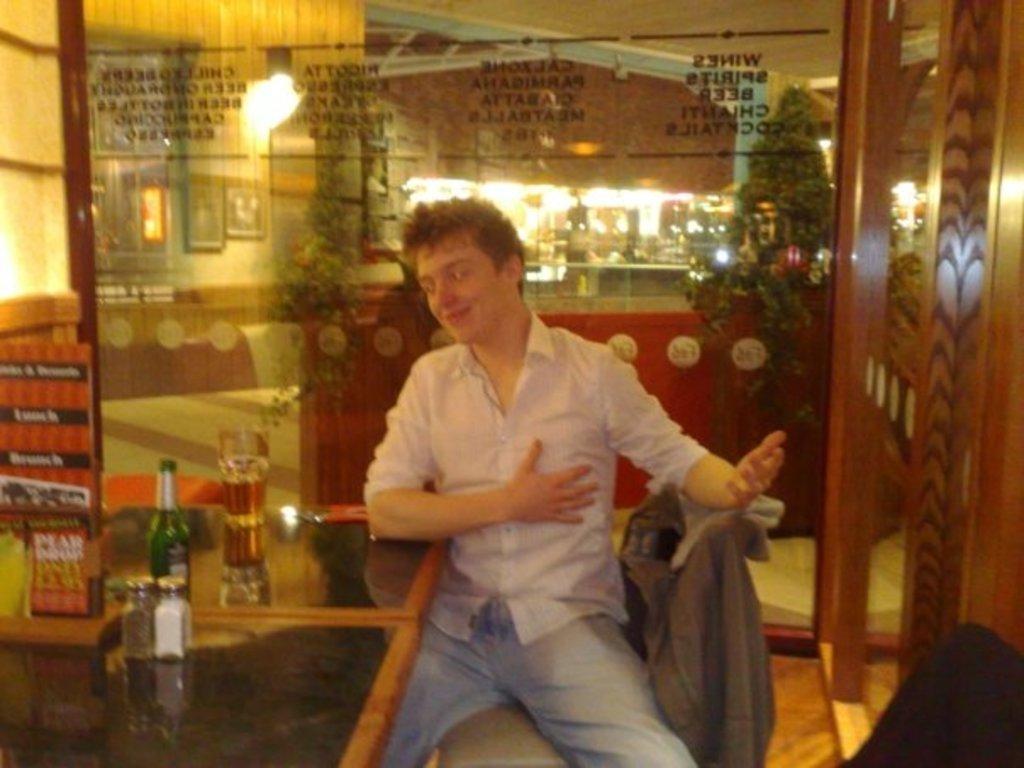Describe this image in one or two sentences. In this image there is a person sitting on a chair, beside the person on the table there is a glass, bottle and some other objects, behind the person there is a glass wall, on the other side of the glass wall there are Christmas trees, a bar counter with beer dispensers and some objects on the platform and there is some text written on the glass. 